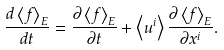Convert formula to latex. <formula><loc_0><loc_0><loc_500><loc_500>\frac { d \left \langle f \right \rangle _ { E } } { d t } = \frac { \partial \left \langle f \right \rangle _ { E } } { \partial t } + \left \langle u ^ { i } \right \rangle \frac { \partial \left \langle f \right \rangle _ { E } } { \partial x ^ { i } } .</formula> 